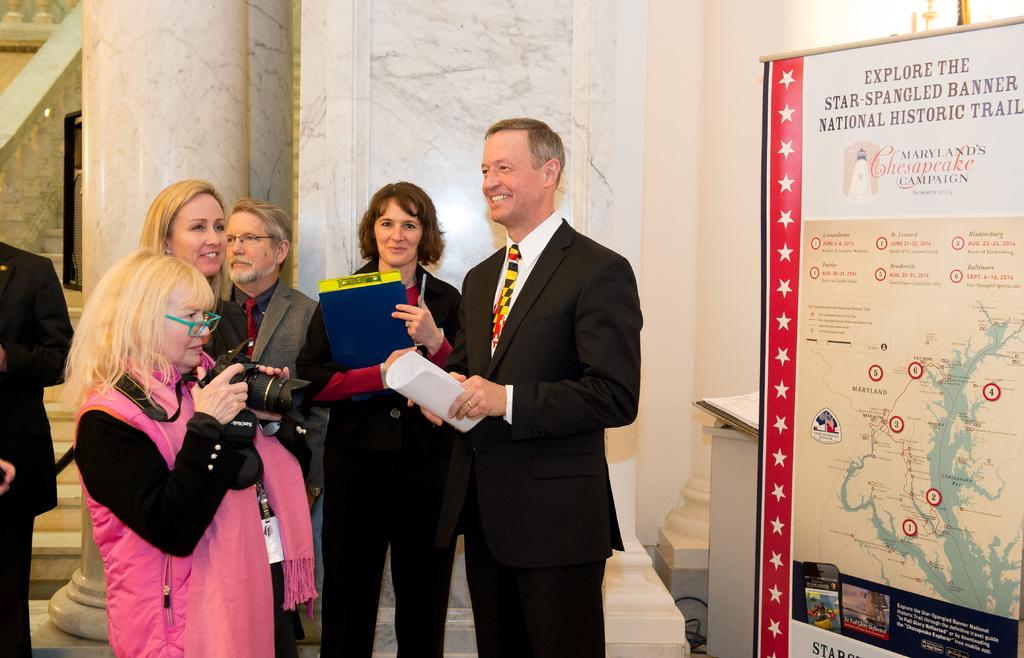What is located on the right side of the image? There is a banner on the right side of the image. What is the woman on the left side of the image doing? The woman on the left side of the image is holding a camera. Can you describe the people in the image? There are people standing in the image. What architectural feature can be seen in the image? There is a pillar visible in the image. What type of property is visible in the image? There is no property visible in the image; it only shows a banner, a woman holding a camera, people standing, and a pillar. How many rooms can be seen in the image? There is no room visible in the image. 